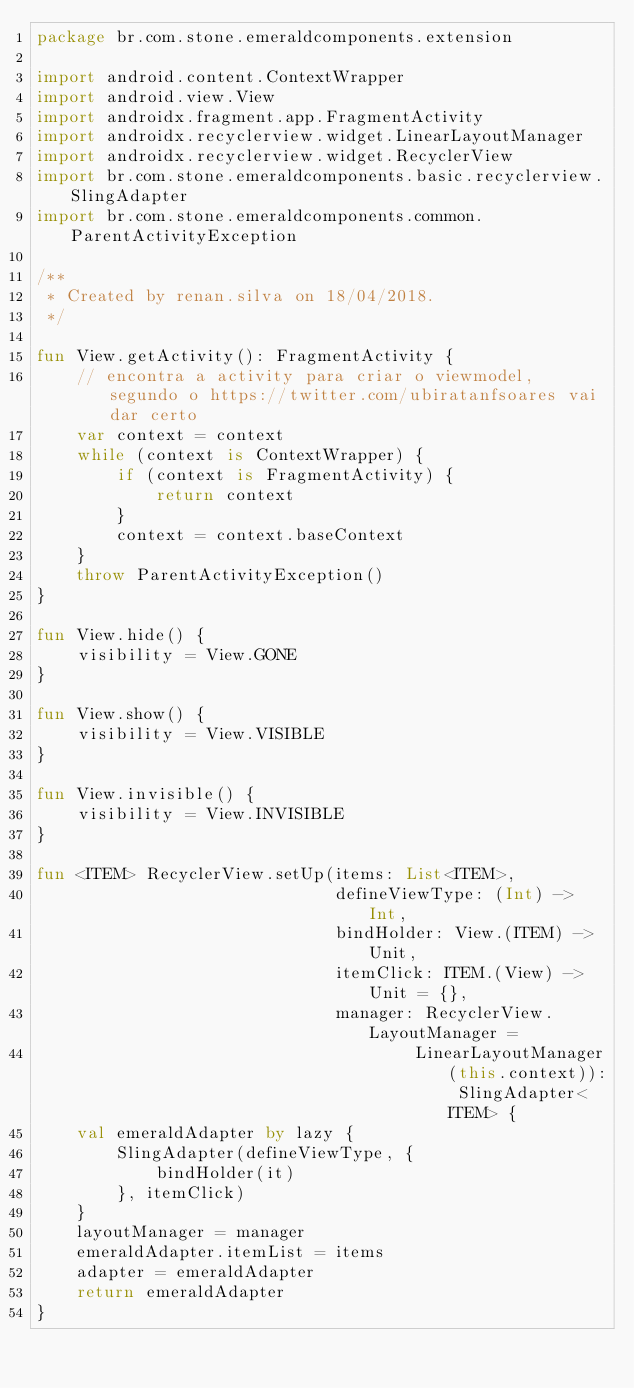Convert code to text. <code><loc_0><loc_0><loc_500><loc_500><_Kotlin_>package br.com.stone.emeraldcomponents.extension

import android.content.ContextWrapper
import android.view.View
import androidx.fragment.app.FragmentActivity
import androidx.recyclerview.widget.LinearLayoutManager
import androidx.recyclerview.widget.RecyclerView
import br.com.stone.emeraldcomponents.basic.recyclerview.SlingAdapter
import br.com.stone.emeraldcomponents.common.ParentActivityException

/**
 * Created by renan.silva on 18/04/2018.
 */

fun View.getActivity(): FragmentActivity {
    // encontra a activity para criar o viewmodel, segundo o https://twitter.com/ubiratanfsoares vai dar certo
    var context = context
    while (context is ContextWrapper) {
        if (context is FragmentActivity) {
            return context
        }
        context = context.baseContext
    }
    throw ParentActivityException()
}

fun View.hide() {
    visibility = View.GONE
}

fun View.show() {
    visibility = View.VISIBLE
}

fun View.invisible() {
    visibility = View.INVISIBLE
}

fun <ITEM> RecyclerView.setUp(items: List<ITEM>,
                              defineViewType: (Int) -> Int,
                              bindHolder: View.(ITEM) -> Unit,
                              itemClick: ITEM.(View) -> Unit = {},
                              manager: RecyclerView.LayoutManager =
                                      LinearLayoutManager(this.context)): SlingAdapter<ITEM> {
    val emeraldAdapter by lazy {
        SlingAdapter(defineViewType, {
            bindHolder(it)
        }, itemClick)
    }
    layoutManager = manager
    emeraldAdapter.itemList = items
    adapter = emeraldAdapter
    return emeraldAdapter
}</code> 